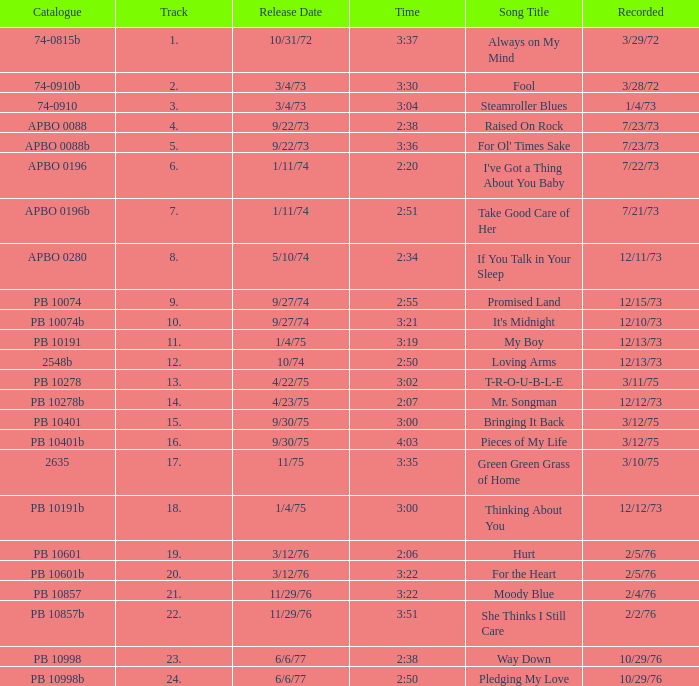Tell me the release date record on 10/29/76 and a time on 2:50 6/6/77. 